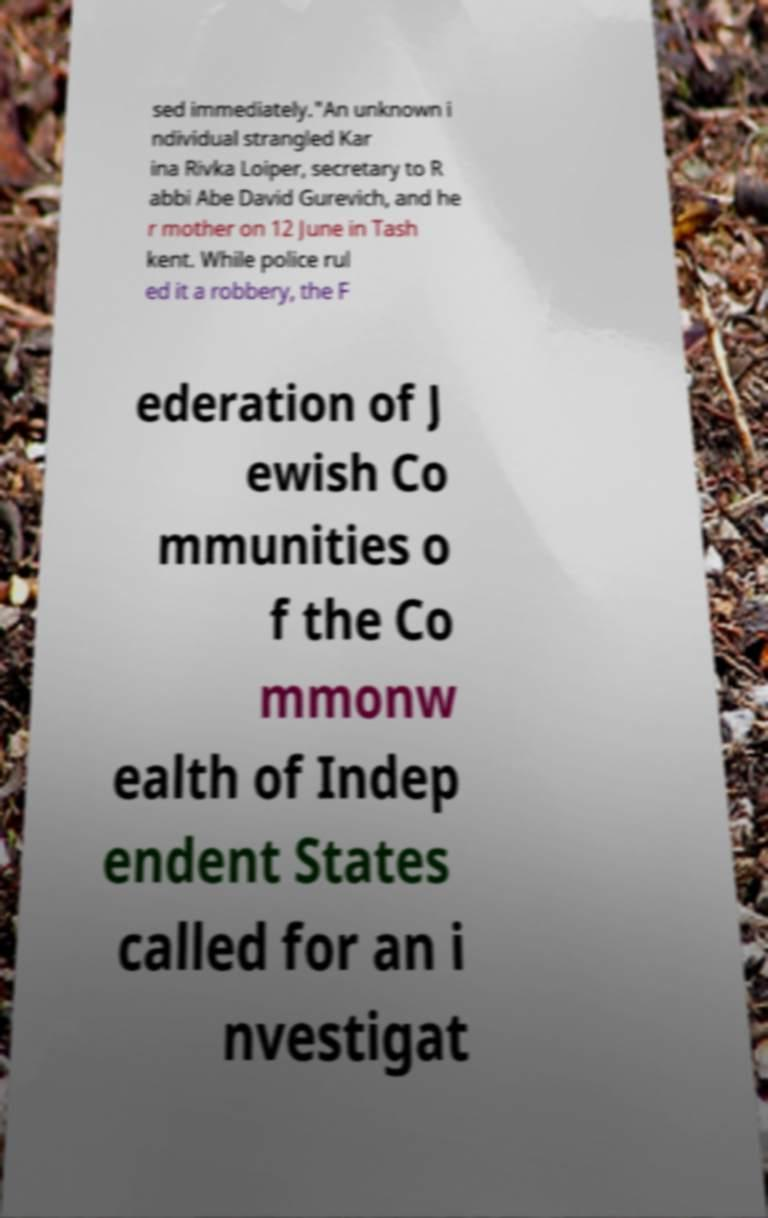Could you extract and type out the text from this image? sed immediately."An unknown i ndividual strangled Kar ina Rivka Loiper, secretary to R abbi Abe David Gurevich, and he r mother on 12 June in Tash kent. While police rul ed it a robbery, the F ederation of J ewish Co mmunities o f the Co mmonw ealth of Indep endent States called for an i nvestigat 